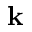Convert formula to latex. <formula><loc_0><loc_0><loc_500><loc_500>k</formula> 